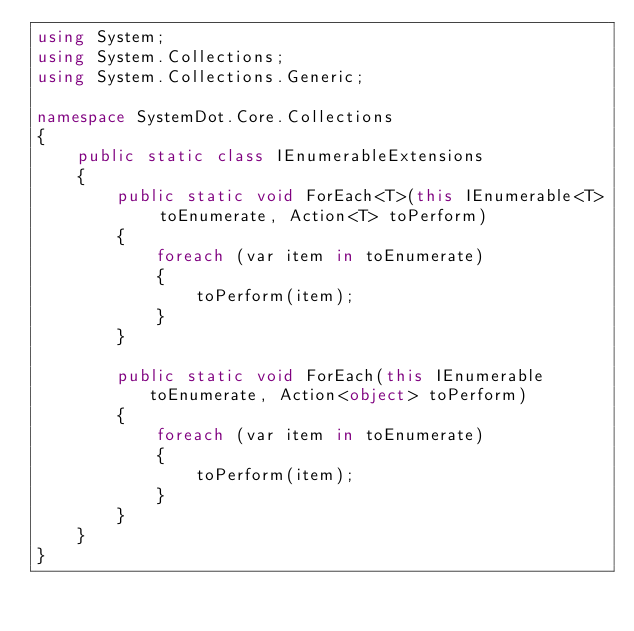<code> <loc_0><loc_0><loc_500><loc_500><_C#_>using System;
using System.Collections;
using System.Collections.Generic;

namespace SystemDot.Core.Collections
{
    public static class IEnumerableExtensions
    {
        public static void ForEach<T>(this IEnumerable<T> toEnumerate, Action<T> toPerform)
        {
            foreach (var item in toEnumerate)
            {
                toPerform(item);
            }
        }

        public static void ForEach(this IEnumerable toEnumerate, Action<object> toPerform)
        {
            foreach (var item in toEnumerate)
            {
                toPerform(item);
            }
        }
    }
}</code> 